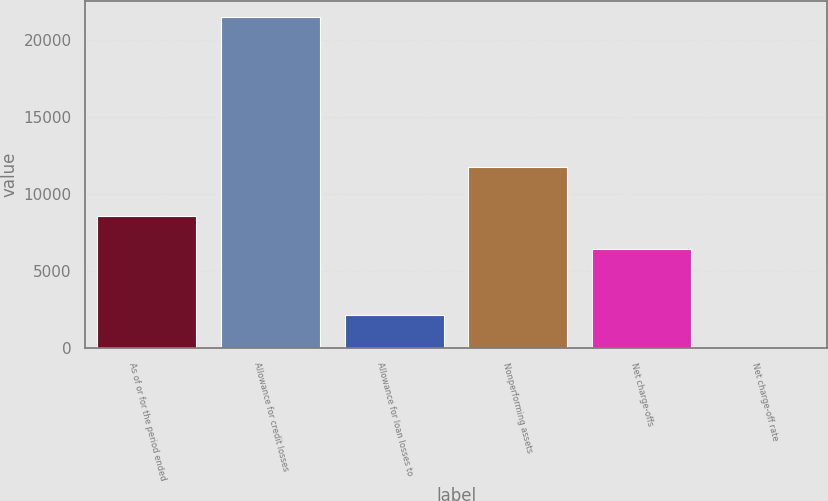<chart> <loc_0><loc_0><loc_500><loc_500><bar_chart><fcel>As of or for the period ended<fcel>Allowance for credit losses<fcel>Allowance for loan losses to<fcel>Nonperforming assets<fcel>Net charge-offs<fcel>Net charge-off rate<nl><fcel>8598.97<fcel>21496<fcel>2150.47<fcel>11739<fcel>6449.47<fcel>0.97<nl></chart> 